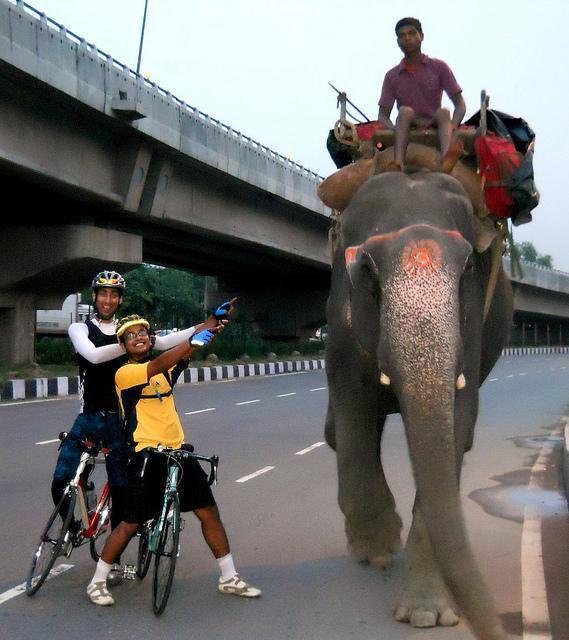Verify the accuracy of this image caption: "The truck is away from the elephant.".
Answer yes or no. Yes. Is the given caption "The truck is below the elephant." fitting for the image?
Answer yes or no. No. Does the description: "The elephant is in the truck." accurately reflect the image?
Answer yes or no. No. Is the caption "The truck is far away from the elephant." a true representation of the image?
Answer yes or no. Yes. 